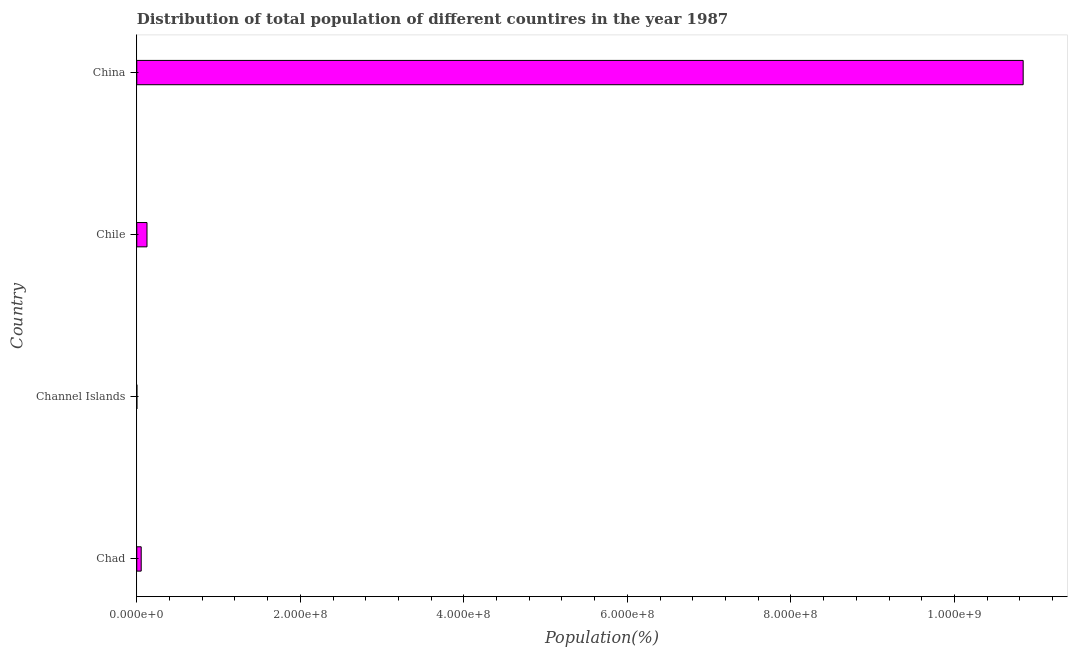Does the graph contain any zero values?
Offer a terse response. No. What is the title of the graph?
Offer a very short reply. Distribution of total population of different countires in the year 1987. What is the label or title of the X-axis?
Make the answer very short. Population(%). What is the label or title of the Y-axis?
Give a very brief answer. Country. What is the population in Chad?
Provide a succinct answer. 5.41e+06. Across all countries, what is the maximum population?
Keep it short and to the point. 1.08e+09. Across all countries, what is the minimum population?
Your answer should be very brief. 1.37e+05. In which country was the population maximum?
Your answer should be compact. China. In which country was the population minimum?
Make the answer very short. Channel Islands. What is the sum of the population?
Offer a very short reply. 1.10e+09. What is the difference between the population in Chad and Chile?
Your response must be concise. -7.10e+06. What is the average population per country?
Your response must be concise. 2.76e+08. What is the median population?
Offer a terse response. 8.96e+06. What is the ratio of the population in Chad to that in Chile?
Offer a very short reply. 0.43. Is the population in Channel Islands less than that in Chile?
Offer a very short reply. Yes. What is the difference between the highest and the second highest population?
Make the answer very short. 1.07e+09. Is the sum of the population in Chad and Channel Islands greater than the maximum population across all countries?
Your answer should be compact. No. What is the difference between the highest and the lowest population?
Offer a terse response. 1.08e+09. In how many countries, is the population greater than the average population taken over all countries?
Your response must be concise. 1. Are all the bars in the graph horizontal?
Provide a short and direct response. Yes. Are the values on the major ticks of X-axis written in scientific E-notation?
Provide a short and direct response. Yes. What is the Population(%) in Chad?
Give a very brief answer. 5.41e+06. What is the Population(%) in Channel Islands?
Ensure brevity in your answer.  1.37e+05. What is the Population(%) in Chile?
Offer a terse response. 1.25e+07. What is the Population(%) in China?
Make the answer very short. 1.08e+09. What is the difference between the Population(%) in Chad and Channel Islands?
Ensure brevity in your answer.  5.27e+06. What is the difference between the Population(%) in Chad and Chile?
Offer a very short reply. -7.10e+06. What is the difference between the Population(%) in Chad and China?
Make the answer very short. -1.08e+09. What is the difference between the Population(%) in Channel Islands and Chile?
Give a very brief answer. -1.24e+07. What is the difference between the Population(%) in Channel Islands and China?
Ensure brevity in your answer.  -1.08e+09. What is the difference between the Population(%) in Chile and China?
Provide a short and direct response. -1.07e+09. What is the ratio of the Population(%) in Chad to that in Channel Islands?
Give a very brief answer. 39.57. What is the ratio of the Population(%) in Chad to that in Chile?
Provide a succinct answer. 0.43. What is the ratio of the Population(%) in Chad to that in China?
Offer a very short reply. 0.01. What is the ratio of the Population(%) in Channel Islands to that in Chile?
Your answer should be very brief. 0.01. What is the ratio of the Population(%) in Chile to that in China?
Your response must be concise. 0.01. 